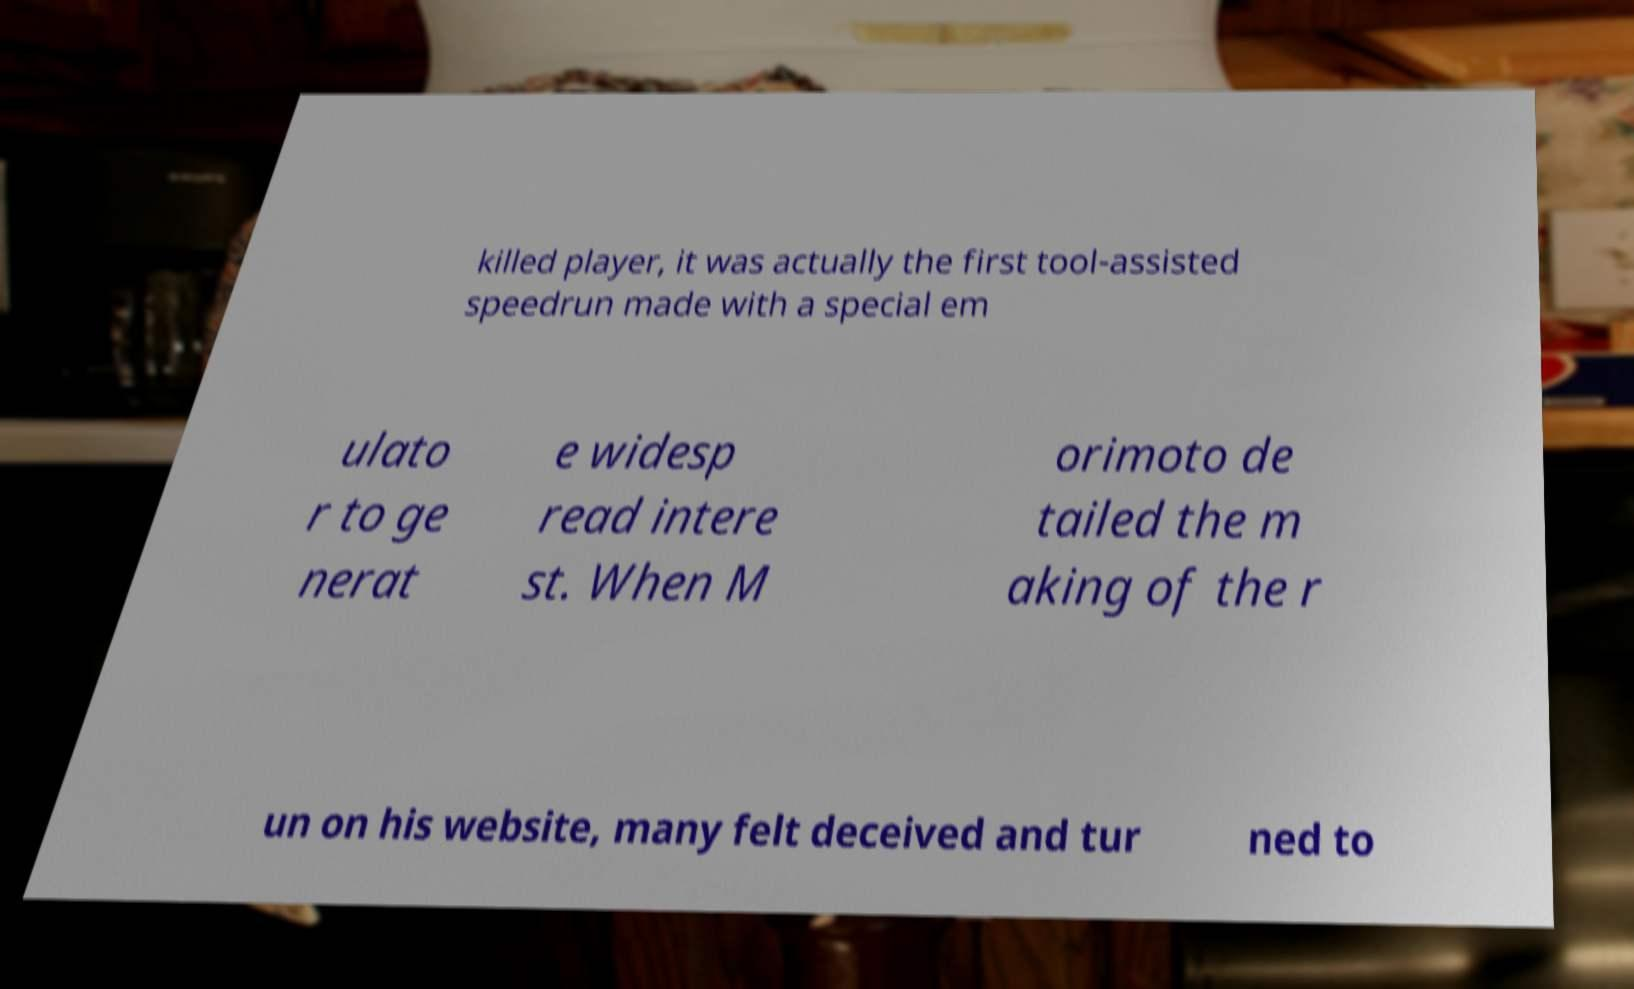Could you extract and type out the text from this image? killed player, it was actually the first tool-assisted speedrun made with a special em ulato r to ge nerat e widesp read intere st. When M orimoto de tailed the m aking of the r un on his website, many felt deceived and tur ned to 